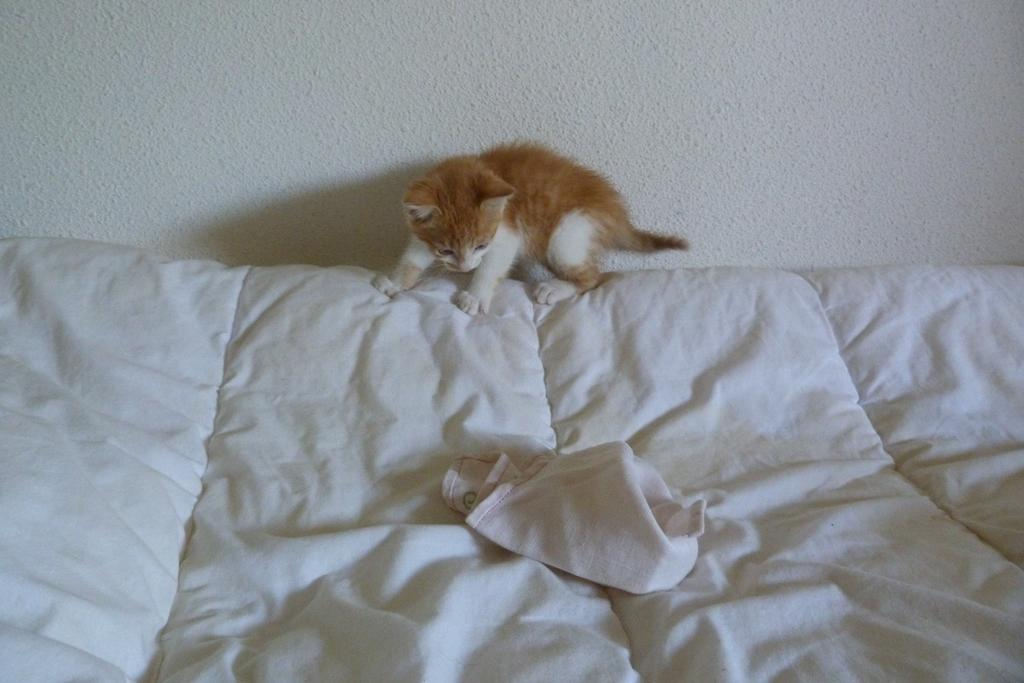What is the main object in the image? There is a white cloth in the image. What is sitting on the white cloth? A cat is sitting on the white cloth. Can you describe the cat's appearance? The cat is yellow in color. What can be seen in the background of the image? There is a white color wall in the background of the image. Are there any clouds visible in the image? No, there are no clouds visible in the image; the background is a white color wall. 